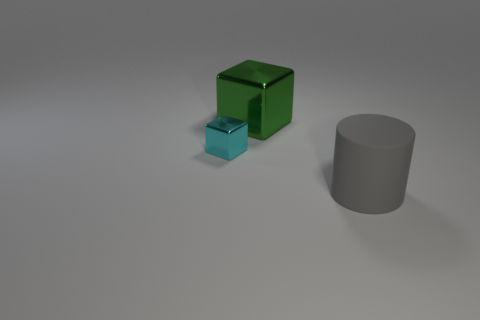Add 3 large green cubes. How many objects exist? 6 Subtract all tiny yellow shiny cylinders. Subtract all small cyan cubes. How many objects are left? 2 Add 1 large rubber objects. How many large rubber objects are left? 2 Add 2 small cyan metallic cubes. How many small cyan metallic cubes exist? 3 Subtract 0 cyan spheres. How many objects are left? 3 Subtract all cubes. How many objects are left? 1 